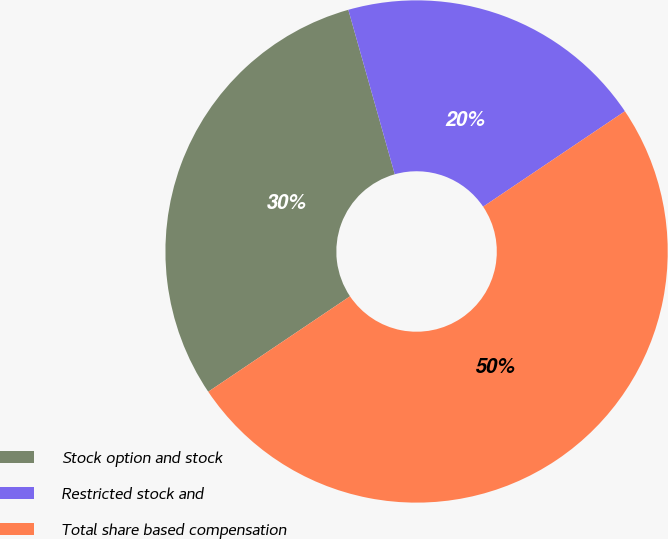Convert chart. <chart><loc_0><loc_0><loc_500><loc_500><pie_chart><fcel>Stock option and stock<fcel>Restricted stock and<fcel>Total share based compensation<nl><fcel>30.05%<fcel>19.95%<fcel>50.0%<nl></chart> 